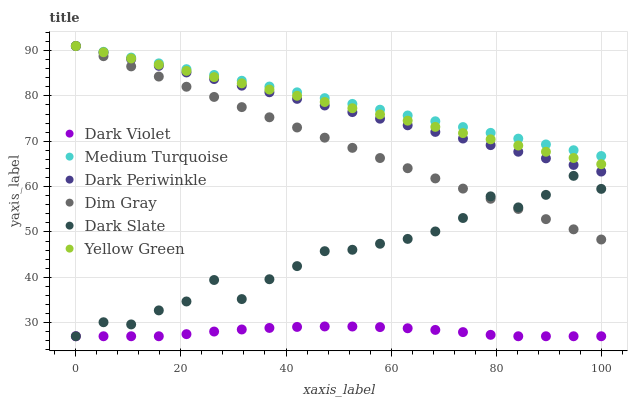Does Dark Violet have the minimum area under the curve?
Answer yes or no. Yes. Does Medium Turquoise have the maximum area under the curve?
Answer yes or no. Yes. Does Yellow Green have the minimum area under the curve?
Answer yes or no. No. Does Yellow Green have the maximum area under the curve?
Answer yes or no. No. Is Yellow Green the smoothest?
Answer yes or no. Yes. Is Dark Slate the roughest?
Answer yes or no. Yes. Is Dark Violet the smoothest?
Answer yes or no. No. Is Dark Violet the roughest?
Answer yes or no. No. Does Dark Violet have the lowest value?
Answer yes or no. Yes. Does Yellow Green have the lowest value?
Answer yes or no. No. Does Dark Periwinkle have the highest value?
Answer yes or no. Yes. Does Dark Violet have the highest value?
Answer yes or no. No. Is Dark Violet less than Dark Periwinkle?
Answer yes or no. Yes. Is Yellow Green greater than Dark Slate?
Answer yes or no. Yes. Does Dark Periwinkle intersect Yellow Green?
Answer yes or no. Yes. Is Dark Periwinkle less than Yellow Green?
Answer yes or no. No. Is Dark Periwinkle greater than Yellow Green?
Answer yes or no. No. Does Dark Violet intersect Dark Periwinkle?
Answer yes or no. No. 